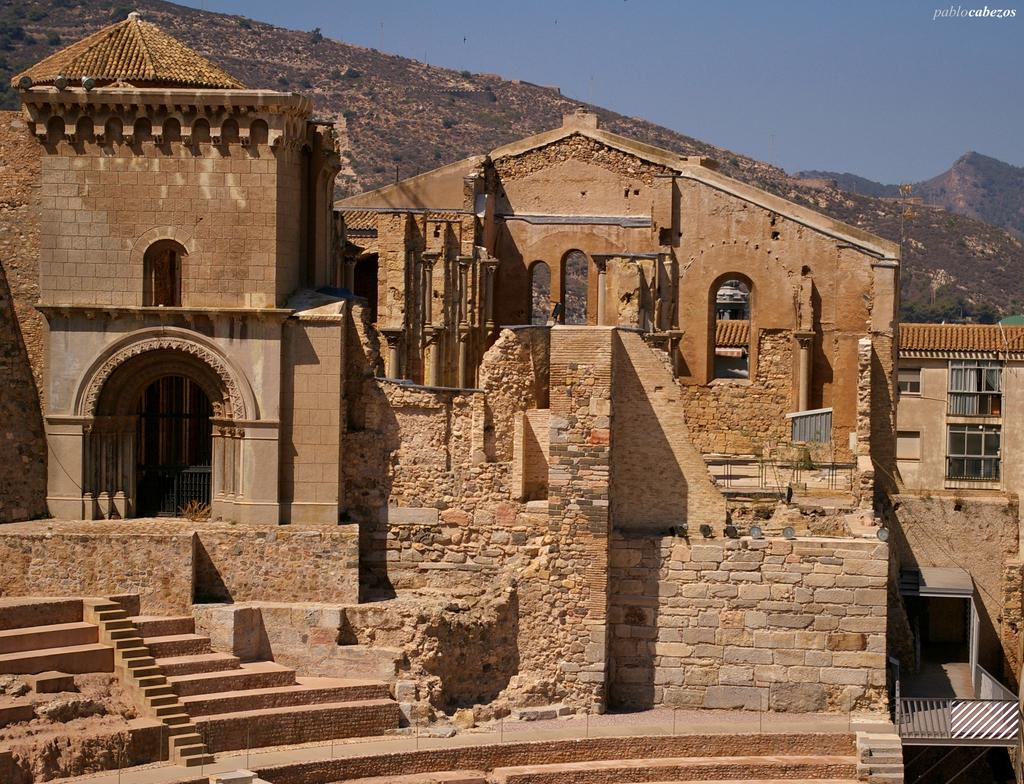What type of structures can be seen in the image? There are buildings in the image. What natural feature is visible in the background of the image? There is a hill visible in the background of the image. What else can be seen in the background of the image? The sky is visible in the background of the image. What type of competition is taking place on the hill in the image? There is no competition present in the image; it only shows buildings, a hill, and the sky. 